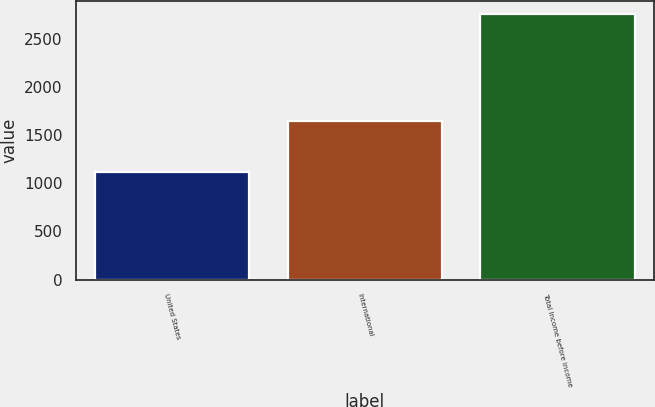Convert chart to OTSL. <chart><loc_0><loc_0><loc_500><loc_500><bar_chart><fcel>United States<fcel>International<fcel>Total Income before income<nl><fcel>1118<fcel>1645<fcel>2763<nl></chart> 